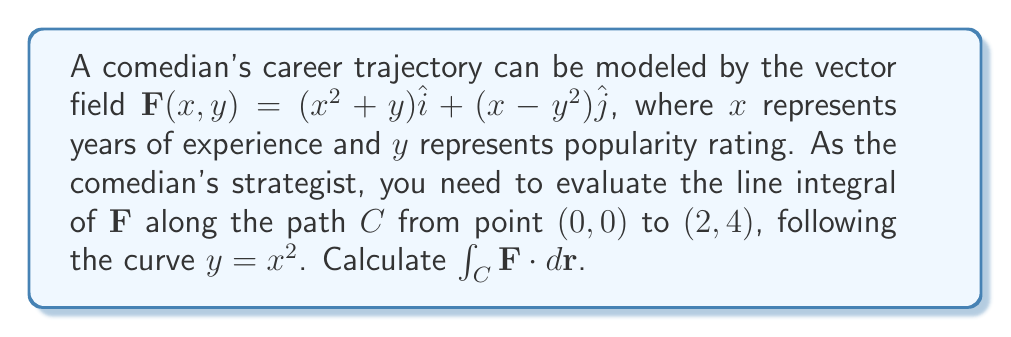Could you help me with this problem? To evaluate the line integral, we'll follow these steps:

1) Parameterize the curve:
   $x = t$, $y = t^2$, where $0 \leq t \leq 2$

2) Calculate $\frac{dx}{dt}$ and $\frac{dy}{dt}$:
   $\frac{dx}{dt} = 1$, $\frac{dy}{dt} = 2t$

3) Substitute into the vector field:
   $\mathbf{F}(t) = (t^2 + t^2)\hat{i} + (t - t^4)\hat{j}$
                 $= 2t^2\hat{i} + (t - t^4)\hat{j}$

4) Set up the line integral:
   $$\int_C \mathbf{F} \cdot d\mathbf{r} = \int_0^2 [(2t^2)(1) + (t - t^4)(2t)] dt$$

5) Simplify:
   $$\int_0^2 (2t^2 + 2t^2 - 2t^5) dt$$
   $$\int_0^2 (4t^2 - 2t^5) dt$$

6) Integrate:
   $$\left[\frac{4t^3}{3} - \frac{2t^6}{6}\right]_0^2$$

7) Evaluate the limits:
   $$(\frac{32}{3} - \frac{128}{6}) - (0 - 0) = \frac{32}{3} - \frac{64}{3} = -\frac{32}{3}$$

Therefore, the line integral evaluates to $-\frac{32}{3}$.
Answer: $-\frac{32}{3}$ 